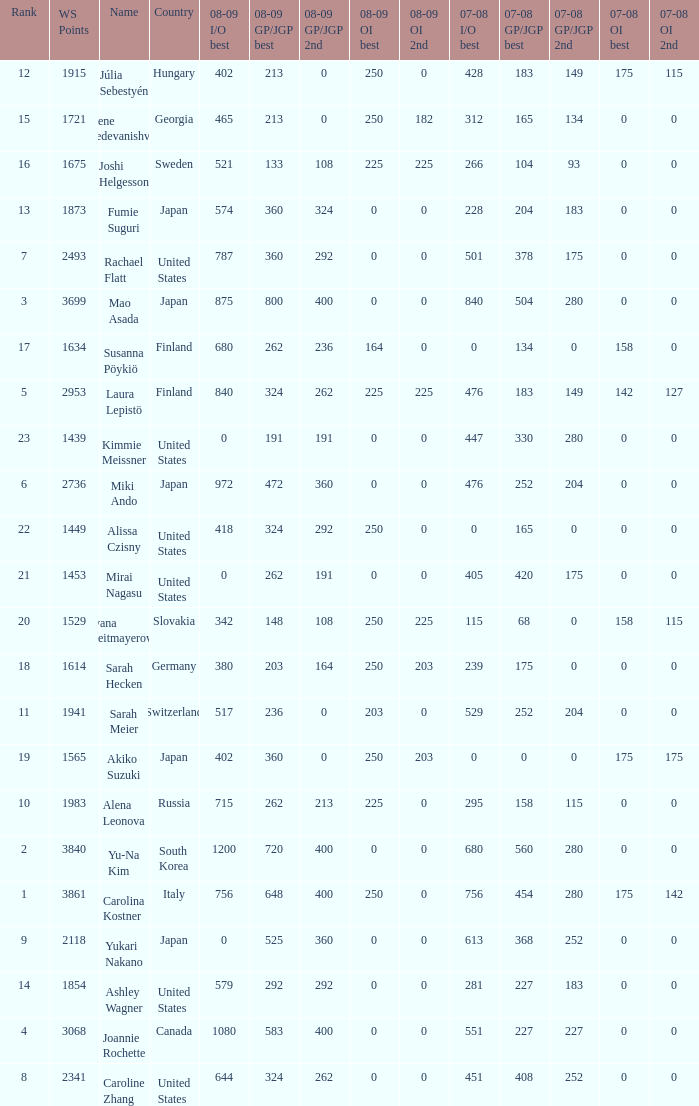What is the total 07-08 gp/jgp 2nd with the name mao asada 280.0. I'm looking to parse the entire table for insights. Could you assist me with that? {'header': ['Rank', 'WS Points', 'Name', 'Country', '08-09 I/O best', '08-09 GP/JGP best', '08-09 GP/JGP 2nd', '08-09 OI best', '08-09 OI 2nd', '07-08 I/O best', '07-08 GP/JGP best', '07-08 GP/JGP 2nd', '07-08 OI best', '07-08 OI 2nd'], 'rows': [['12', '1915', 'Júlia Sebestyén', 'Hungary', '402', '213', '0', '250', '0', '428', '183', '149', '175', '115'], ['15', '1721', 'Elene Gedevanishvili', 'Georgia', '465', '213', '0', '250', '182', '312', '165', '134', '0', '0'], ['16', '1675', 'Joshi Helgesson', 'Sweden', '521', '133', '108', '225', '225', '266', '104', '93', '0', '0'], ['13', '1873', 'Fumie Suguri', 'Japan', '574', '360', '324', '0', '0', '228', '204', '183', '0', '0'], ['7', '2493', 'Rachael Flatt', 'United States', '787', '360', '292', '0', '0', '501', '378', '175', '0', '0'], ['3', '3699', 'Mao Asada', 'Japan', '875', '800', '400', '0', '0', '840', '504', '280', '0', '0'], ['17', '1634', 'Susanna Pöykiö', 'Finland', '680', '262', '236', '164', '0', '0', '134', '0', '158', '0'], ['5', '2953', 'Laura Lepistö', 'Finland', '840', '324', '262', '225', '225', '476', '183', '149', '142', '127'], ['23', '1439', 'Kimmie Meissner', 'United States', '0', '191', '191', '0', '0', '447', '330', '280', '0', '0'], ['6', '2736', 'Miki Ando', 'Japan', '972', '472', '360', '0', '0', '476', '252', '204', '0', '0'], ['22', '1449', 'Alissa Czisny', 'United States', '418', '324', '292', '250', '0', '0', '165', '0', '0', '0'], ['21', '1453', 'Mirai Nagasu', 'United States', '0', '262', '191', '0', '0', '405', '420', '175', '0', '0'], ['20', '1529', 'Ivana Reitmayerova', 'Slovakia', '342', '148', '108', '250', '225', '115', '68', '0', '158', '115'], ['18', '1614', 'Sarah Hecken', 'Germany', '380', '203', '164', '250', '203', '239', '175', '0', '0', '0'], ['11', '1941', 'Sarah Meier', 'Switzerland', '517', '236', '0', '203', '0', '529', '252', '204', '0', '0'], ['19', '1565', 'Akiko Suzuki', 'Japan', '402', '360', '0', '250', '203', '0', '0', '0', '175', '175'], ['10', '1983', 'Alena Leonova', 'Russia', '715', '262', '213', '225', '0', '295', '158', '115', '0', '0'], ['2', '3840', 'Yu-Na Kim', 'South Korea', '1200', '720', '400', '0', '0', '680', '560', '280', '0', '0'], ['1', '3861', 'Carolina Kostner', 'Italy', '756', '648', '400', '250', '0', '756', '454', '280', '175', '142'], ['9', '2118', 'Yukari Nakano', 'Japan', '0', '525', '360', '0', '0', '613', '368', '252', '0', '0'], ['14', '1854', 'Ashley Wagner', 'United States', '579', '292', '292', '0', '0', '281', '227', '183', '0', '0'], ['4', '3068', 'Joannie Rochette', 'Canada', '1080', '583', '400', '0', '0', '551', '227', '227', '0', '0'], ['8', '2341', 'Caroline Zhang', 'United States', '644', '324', '262', '0', '0', '451', '408', '252', '0', '0']]} 